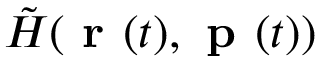<formula> <loc_0><loc_0><loc_500><loc_500>\tilde { H } ( r ( t ) , p ( t ) )</formula> 